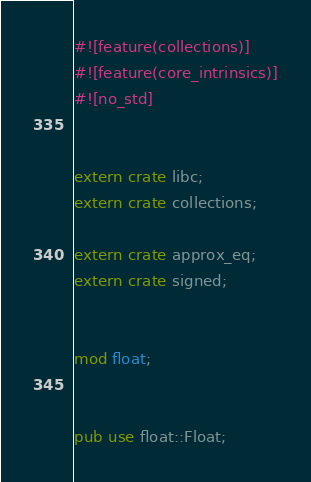Convert code to text. <code><loc_0><loc_0><loc_500><loc_500><_Rust_>#![feature(collections)]
#![feature(core_intrinsics)]
#![no_std]


extern crate libc;
extern crate collections;

extern crate approx_eq;
extern crate signed;


mod float;


pub use float::Float;
</code> 